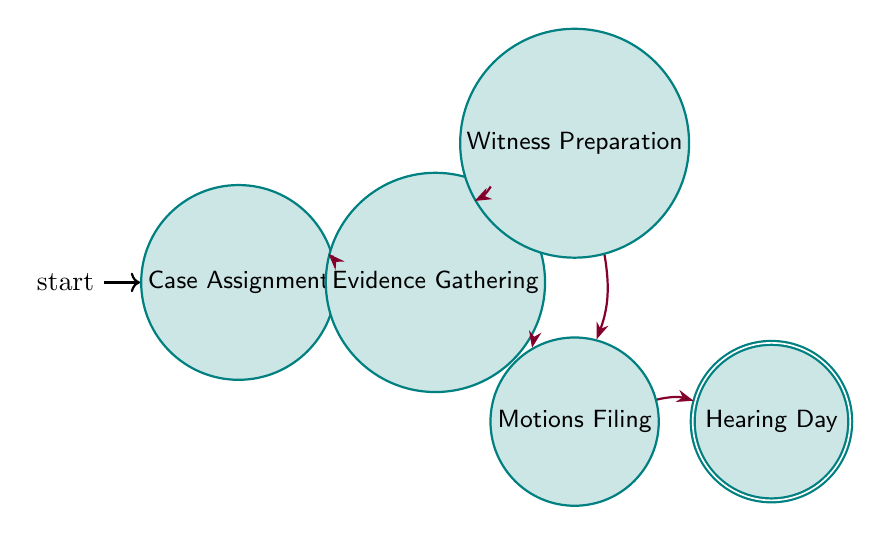What is the first state in the process? The first state in the diagram is labeled "Case Assignment," indicating the starting point of the court hearing preparation process.
Answer: Case Assignment Which state directly follows "Case Assignment"? The state that directly follows "Case Assignment" is "Evidence Gathering," indicating the next step in the process after assignment of the case.
Answer: Evidence Gathering How many total states are there in the diagram? The diagram has a total of five states: "Case Assignment," "Evidence Gathering," "Witness Preparation," "Motions Filing," and "Hearing Day."
Answer: Five From "Evidence Gathering," how many possible next states are there? From the "Evidence Gathering" state, there are two possible next states: "Witness Preparation" and "Motions Filing," indicating choices available after gathering evidence.
Answer: Two Which state has no outgoing transitions? The state "Hearing Day" has no outgoing transitions, meaning it is the final state in the preparation process with no further actions to take afterward.
Answer: Hearing Day What is the relationship between "Witness Preparation" and "Motions Filing"? "Witness Preparation" has a direct transition to "Motions Filing," indicating that after preparing witnesses, the next step involves filing motions.
Answer: Direct transition Is it possible to move from "Case Assignment" to "Witness Preparation" directly? No, there is no direct transition from "Case Assignment" to "Witness Preparation"; the only transition from "Case Assignment" is to "Evidence Gathering."
Answer: No After "Motions Filing," what is the next state? The next state after "Motions Filing" is "Hearing Day," indicating the concluding step after all motions have been filed.
Answer: Hearing Day 